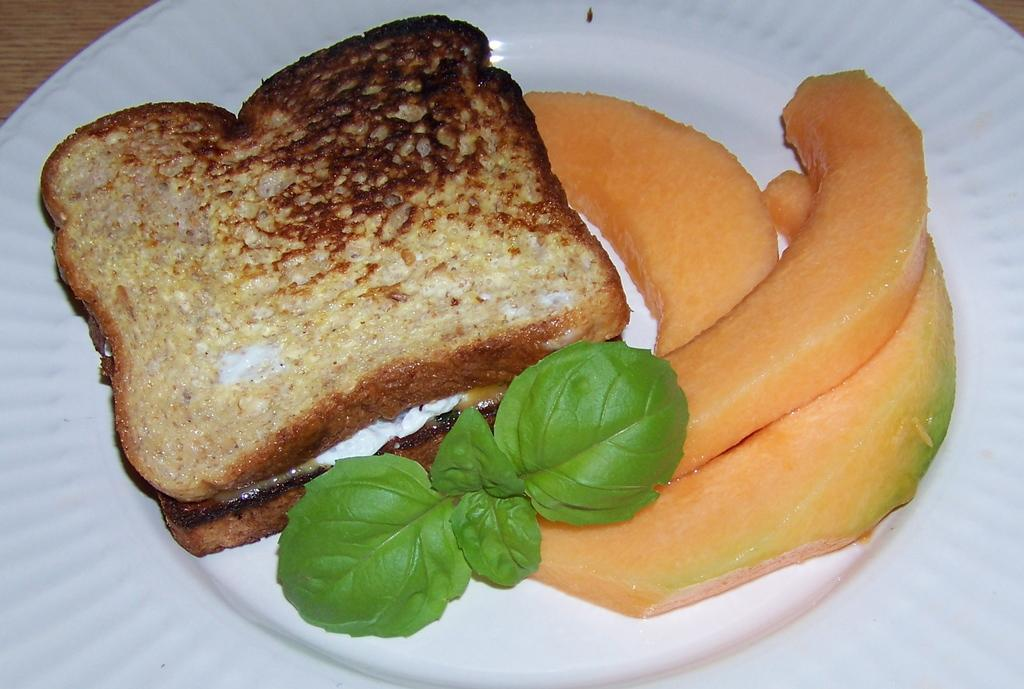What piece of furniture is present in the image? There is a table in the image. What is placed on the table? There is a plate on the table. What type of food is on the plate? There are two toasts, a mint leaf, and melon slices on the plate. Is there any evidence of a brain or an earthquake in the image? No, there is no evidence of a brain or an earthquake in the image. Can you see any quicksand in the image? No, there is no quicksand present in the image. 